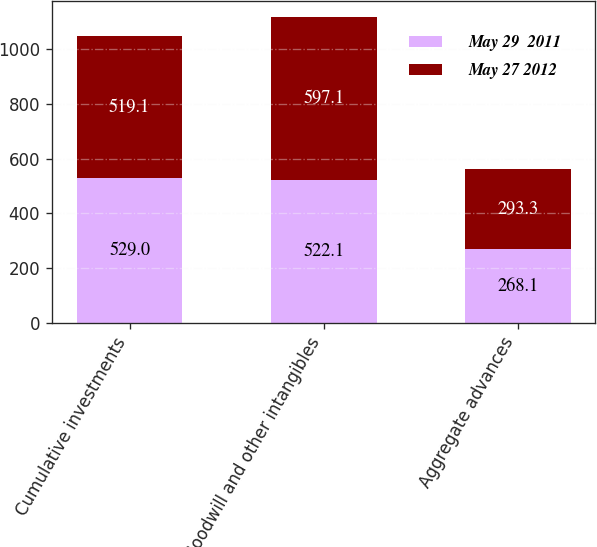Convert chart to OTSL. <chart><loc_0><loc_0><loc_500><loc_500><stacked_bar_chart><ecel><fcel>Cumulative investments<fcel>Goodwill and other intangibles<fcel>Aggregate advances<nl><fcel>May 29  2011<fcel>529<fcel>522.1<fcel>268.1<nl><fcel>May 27 2012<fcel>519.1<fcel>597.1<fcel>293.3<nl></chart> 